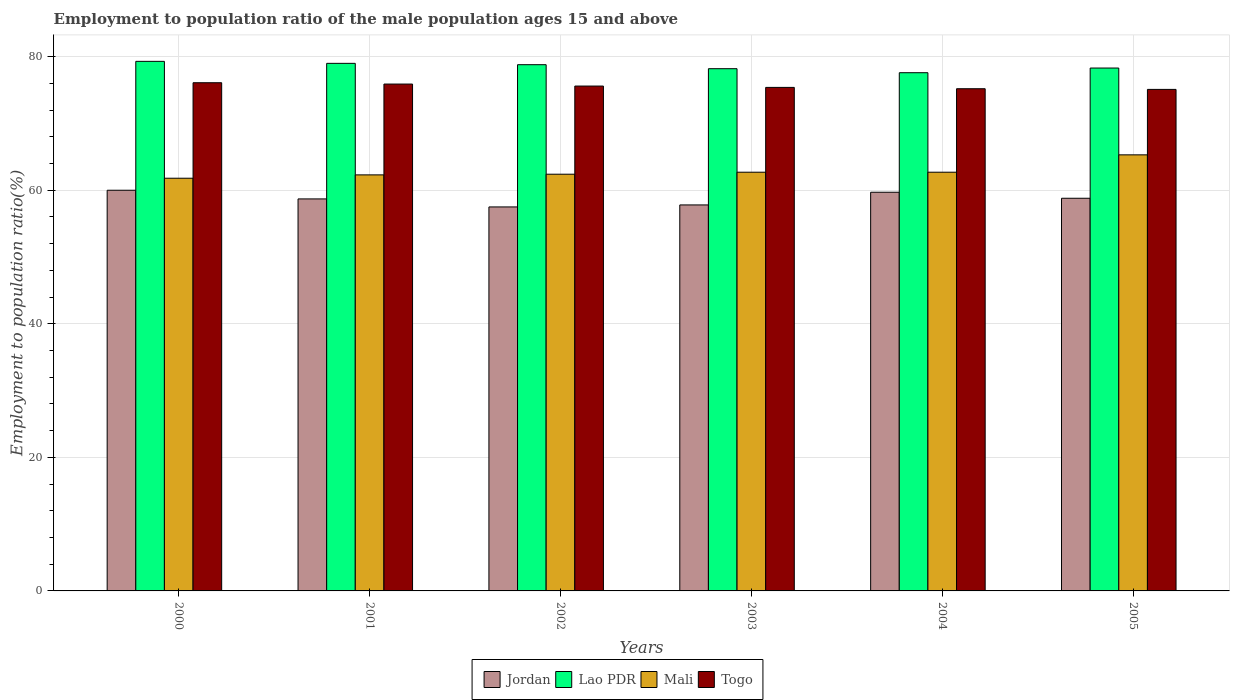Are the number of bars on each tick of the X-axis equal?
Provide a succinct answer. Yes. How many bars are there on the 1st tick from the right?
Make the answer very short. 4. What is the label of the 5th group of bars from the left?
Keep it short and to the point. 2004. In how many cases, is the number of bars for a given year not equal to the number of legend labels?
Provide a succinct answer. 0. What is the employment to population ratio in Jordan in 2001?
Keep it short and to the point. 58.7. Across all years, what is the maximum employment to population ratio in Lao PDR?
Offer a terse response. 79.3. Across all years, what is the minimum employment to population ratio in Togo?
Provide a short and direct response. 75.1. In which year was the employment to population ratio in Lao PDR maximum?
Make the answer very short. 2000. What is the total employment to population ratio in Mali in the graph?
Your answer should be very brief. 377.2. What is the difference between the employment to population ratio in Mali in 2000 and that in 2005?
Your answer should be compact. -3.5. What is the difference between the employment to population ratio in Jordan in 2003 and the employment to population ratio in Mali in 2004?
Provide a succinct answer. -4.9. What is the average employment to population ratio in Jordan per year?
Offer a terse response. 58.75. In the year 2004, what is the difference between the employment to population ratio in Lao PDR and employment to population ratio in Jordan?
Make the answer very short. 17.9. What is the ratio of the employment to population ratio in Mali in 2003 to that in 2004?
Offer a very short reply. 1. Is the difference between the employment to population ratio in Lao PDR in 2000 and 2002 greater than the difference between the employment to population ratio in Jordan in 2000 and 2002?
Ensure brevity in your answer.  No. What is the difference between the highest and the second highest employment to population ratio in Lao PDR?
Offer a terse response. 0.3. What is the difference between the highest and the lowest employment to population ratio in Lao PDR?
Provide a short and direct response. 1.7. Is it the case that in every year, the sum of the employment to population ratio in Togo and employment to population ratio in Mali is greater than the sum of employment to population ratio in Jordan and employment to population ratio in Lao PDR?
Provide a short and direct response. Yes. What does the 1st bar from the left in 2005 represents?
Your response must be concise. Jordan. What does the 3rd bar from the right in 2000 represents?
Offer a terse response. Lao PDR. How many bars are there?
Provide a short and direct response. 24. Are all the bars in the graph horizontal?
Your answer should be compact. No. Are the values on the major ticks of Y-axis written in scientific E-notation?
Your response must be concise. No. Does the graph contain any zero values?
Your answer should be very brief. No. Does the graph contain grids?
Make the answer very short. Yes. How many legend labels are there?
Keep it short and to the point. 4. What is the title of the graph?
Your answer should be very brief. Employment to population ratio of the male population ages 15 and above. What is the label or title of the X-axis?
Make the answer very short. Years. What is the Employment to population ratio(%) in Lao PDR in 2000?
Ensure brevity in your answer.  79.3. What is the Employment to population ratio(%) of Mali in 2000?
Provide a short and direct response. 61.8. What is the Employment to population ratio(%) in Togo in 2000?
Give a very brief answer. 76.1. What is the Employment to population ratio(%) in Jordan in 2001?
Your answer should be compact. 58.7. What is the Employment to population ratio(%) of Lao PDR in 2001?
Ensure brevity in your answer.  79. What is the Employment to population ratio(%) of Mali in 2001?
Offer a terse response. 62.3. What is the Employment to population ratio(%) in Togo in 2001?
Offer a terse response. 75.9. What is the Employment to population ratio(%) of Jordan in 2002?
Your response must be concise. 57.5. What is the Employment to population ratio(%) in Lao PDR in 2002?
Your answer should be compact. 78.8. What is the Employment to population ratio(%) in Mali in 2002?
Your answer should be compact. 62.4. What is the Employment to population ratio(%) of Togo in 2002?
Offer a very short reply. 75.6. What is the Employment to population ratio(%) of Jordan in 2003?
Your response must be concise. 57.8. What is the Employment to population ratio(%) in Lao PDR in 2003?
Ensure brevity in your answer.  78.2. What is the Employment to population ratio(%) of Mali in 2003?
Make the answer very short. 62.7. What is the Employment to population ratio(%) in Togo in 2003?
Offer a very short reply. 75.4. What is the Employment to population ratio(%) in Jordan in 2004?
Give a very brief answer. 59.7. What is the Employment to population ratio(%) in Lao PDR in 2004?
Make the answer very short. 77.6. What is the Employment to population ratio(%) in Mali in 2004?
Make the answer very short. 62.7. What is the Employment to population ratio(%) of Togo in 2004?
Make the answer very short. 75.2. What is the Employment to population ratio(%) in Jordan in 2005?
Provide a succinct answer. 58.8. What is the Employment to population ratio(%) in Lao PDR in 2005?
Ensure brevity in your answer.  78.3. What is the Employment to population ratio(%) of Mali in 2005?
Give a very brief answer. 65.3. What is the Employment to population ratio(%) in Togo in 2005?
Your answer should be very brief. 75.1. Across all years, what is the maximum Employment to population ratio(%) of Jordan?
Give a very brief answer. 60. Across all years, what is the maximum Employment to population ratio(%) of Lao PDR?
Make the answer very short. 79.3. Across all years, what is the maximum Employment to population ratio(%) of Mali?
Give a very brief answer. 65.3. Across all years, what is the maximum Employment to population ratio(%) of Togo?
Provide a succinct answer. 76.1. Across all years, what is the minimum Employment to population ratio(%) in Jordan?
Provide a short and direct response. 57.5. Across all years, what is the minimum Employment to population ratio(%) in Lao PDR?
Make the answer very short. 77.6. Across all years, what is the minimum Employment to population ratio(%) in Mali?
Provide a short and direct response. 61.8. Across all years, what is the minimum Employment to population ratio(%) in Togo?
Give a very brief answer. 75.1. What is the total Employment to population ratio(%) in Jordan in the graph?
Make the answer very short. 352.5. What is the total Employment to population ratio(%) in Lao PDR in the graph?
Your response must be concise. 471.2. What is the total Employment to population ratio(%) of Mali in the graph?
Offer a very short reply. 377.2. What is the total Employment to population ratio(%) of Togo in the graph?
Provide a short and direct response. 453.3. What is the difference between the Employment to population ratio(%) in Jordan in 2000 and that in 2001?
Offer a terse response. 1.3. What is the difference between the Employment to population ratio(%) in Togo in 2000 and that in 2001?
Your answer should be compact. 0.2. What is the difference between the Employment to population ratio(%) of Togo in 2000 and that in 2002?
Keep it short and to the point. 0.5. What is the difference between the Employment to population ratio(%) in Jordan in 2000 and that in 2003?
Provide a short and direct response. 2.2. What is the difference between the Employment to population ratio(%) of Mali in 2000 and that in 2003?
Your response must be concise. -0.9. What is the difference between the Employment to population ratio(%) of Jordan in 2000 and that in 2004?
Offer a very short reply. 0.3. What is the difference between the Employment to population ratio(%) of Mali in 2000 and that in 2004?
Offer a terse response. -0.9. What is the difference between the Employment to population ratio(%) of Togo in 2000 and that in 2004?
Your answer should be very brief. 0.9. What is the difference between the Employment to population ratio(%) in Jordan in 2000 and that in 2005?
Your answer should be compact. 1.2. What is the difference between the Employment to population ratio(%) in Mali in 2000 and that in 2005?
Keep it short and to the point. -3.5. What is the difference between the Employment to population ratio(%) in Togo in 2000 and that in 2005?
Your answer should be compact. 1. What is the difference between the Employment to population ratio(%) in Lao PDR in 2001 and that in 2002?
Your answer should be compact. 0.2. What is the difference between the Employment to population ratio(%) of Mali in 2001 and that in 2002?
Ensure brevity in your answer.  -0.1. What is the difference between the Employment to population ratio(%) in Togo in 2001 and that in 2002?
Offer a terse response. 0.3. What is the difference between the Employment to population ratio(%) of Jordan in 2001 and that in 2003?
Offer a very short reply. 0.9. What is the difference between the Employment to population ratio(%) in Lao PDR in 2001 and that in 2003?
Your answer should be very brief. 0.8. What is the difference between the Employment to population ratio(%) in Mali in 2001 and that in 2003?
Provide a short and direct response. -0.4. What is the difference between the Employment to population ratio(%) in Mali in 2001 and that in 2004?
Provide a short and direct response. -0.4. What is the difference between the Employment to population ratio(%) in Jordan in 2001 and that in 2005?
Offer a terse response. -0.1. What is the difference between the Employment to population ratio(%) of Lao PDR in 2001 and that in 2005?
Provide a succinct answer. 0.7. What is the difference between the Employment to population ratio(%) in Togo in 2001 and that in 2005?
Offer a very short reply. 0.8. What is the difference between the Employment to population ratio(%) in Jordan in 2002 and that in 2003?
Offer a very short reply. -0.3. What is the difference between the Employment to population ratio(%) of Mali in 2003 and that in 2004?
Ensure brevity in your answer.  0. What is the difference between the Employment to population ratio(%) in Togo in 2003 and that in 2004?
Offer a very short reply. 0.2. What is the difference between the Employment to population ratio(%) of Mali in 2003 and that in 2005?
Offer a terse response. -2.6. What is the difference between the Employment to population ratio(%) in Lao PDR in 2004 and that in 2005?
Your answer should be very brief. -0.7. What is the difference between the Employment to population ratio(%) of Togo in 2004 and that in 2005?
Give a very brief answer. 0.1. What is the difference between the Employment to population ratio(%) in Jordan in 2000 and the Employment to population ratio(%) in Lao PDR in 2001?
Provide a short and direct response. -19. What is the difference between the Employment to population ratio(%) in Jordan in 2000 and the Employment to population ratio(%) in Togo in 2001?
Provide a short and direct response. -15.9. What is the difference between the Employment to population ratio(%) in Lao PDR in 2000 and the Employment to population ratio(%) in Mali in 2001?
Give a very brief answer. 17. What is the difference between the Employment to population ratio(%) of Mali in 2000 and the Employment to population ratio(%) of Togo in 2001?
Your answer should be very brief. -14.1. What is the difference between the Employment to population ratio(%) in Jordan in 2000 and the Employment to population ratio(%) in Lao PDR in 2002?
Offer a very short reply. -18.8. What is the difference between the Employment to population ratio(%) of Jordan in 2000 and the Employment to population ratio(%) of Mali in 2002?
Your response must be concise. -2.4. What is the difference between the Employment to population ratio(%) in Jordan in 2000 and the Employment to population ratio(%) in Togo in 2002?
Provide a succinct answer. -15.6. What is the difference between the Employment to population ratio(%) in Lao PDR in 2000 and the Employment to population ratio(%) in Mali in 2002?
Your answer should be compact. 16.9. What is the difference between the Employment to population ratio(%) of Lao PDR in 2000 and the Employment to population ratio(%) of Togo in 2002?
Your answer should be compact. 3.7. What is the difference between the Employment to population ratio(%) of Jordan in 2000 and the Employment to population ratio(%) of Lao PDR in 2003?
Provide a short and direct response. -18.2. What is the difference between the Employment to population ratio(%) of Jordan in 2000 and the Employment to population ratio(%) of Togo in 2003?
Offer a very short reply. -15.4. What is the difference between the Employment to population ratio(%) in Lao PDR in 2000 and the Employment to population ratio(%) in Mali in 2003?
Ensure brevity in your answer.  16.6. What is the difference between the Employment to population ratio(%) in Mali in 2000 and the Employment to population ratio(%) in Togo in 2003?
Provide a succinct answer. -13.6. What is the difference between the Employment to population ratio(%) of Jordan in 2000 and the Employment to population ratio(%) of Lao PDR in 2004?
Provide a short and direct response. -17.6. What is the difference between the Employment to population ratio(%) of Jordan in 2000 and the Employment to population ratio(%) of Togo in 2004?
Make the answer very short. -15.2. What is the difference between the Employment to population ratio(%) of Lao PDR in 2000 and the Employment to population ratio(%) of Mali in 2004?
Your response must be concise. 16.6. What is the difference between the Employment to population ratio(%) of Mali in 2000 and the Employment to population ratio(%) of Togo in 2004?
Make the answer very short. -13.4. What is the difference between the Employment to population ratio(%) of Jordan in 2000 and the Employment to population ratio(%) of Lao PDR in 2005?
Ensure brevity in your answer.  -18.3. What is the difference between the Employment to population ratio(%) in Jordan in 2000 and the Employment to population ratio(%) in Togo in 2005?
Your answer should be compact. -15.1. What is the difference between the Employment to population ratio(%) in Jordan in 2001 and the Employment to population ratio(%) in Lao PDR in 2002?
Your answer should be compact. -20.1. What is the difference between the Employment to population ratio(%) of Jordan in 2001 and the Employment to population ratio(%) of Mali in 2002?
Give a very brief answer. -3.7. What is the difference between the Employment to population ratio(%) in Jordan in 2001 and the Employment to population ratio(%) in Togo in 2002?
Ensure brevity in your answer.  -16.9. What is the difference between the Employment to population ratio(%) of Lao PDR in 2001 and the Employment to population ratio(%) of Togo in 2002?
Your answer should be very brief. 3.4. What is the difference between the Employment to population ratio(%) in Jordan in 2001 and the Employment to population ratio(%) in Lao PDR in 2003?
Provide a short and direct response. -19.5. What is the difference between the Employment to population ratio(%) in Jordan in 2001 and the Employment to population ratio(%) in Togo in 2003?
Give a very brief answer. -16.7. What is the difference between the Employment to population ratio(%) in Lao PDR in 2001 and the Employment to population ratio(%) in Mali in 2003?
Provide a short and direct response. 16.3. What is the difference between the Employment to population ratio(%) of Jordan in 2001 and the Employment to population ratio(%) of Lao PDR in 2004?
Provide a succinct answer. -18.9. What is the difference between the Employment to population ratio(%) of Jordan in 2001 and the Employment to population ratio(%) of Togo in 2004?
Your response must be concise. -16.5. What is the difference between the Employment to population ratio(%) of Lao PDR in 2001 and the Employment to population ratio(%) of Togo in 2004?
Make the answer very short. 3.8. What is the difference between the Employment to population ratio(%) of Jordan in 2001 and the Employment to population ratio(%) of Lao PDR in 2005?
Make the answer very short. -19.6. What is the difference between the Employment to population ratio(%) in Jordan in 2001 and the Employment to population ratio(%) in Mali in 2005?
Ensure brevity in your answer.  -6.6. What is the difference between the Employment to population ratio(%) of Jordan in 2001 and the Employment to population ratio(%) of Togo in 2005?
Offer a very short reply. -16.4. What is the difference between the Employment to population ratio(%) in Lao PDR in 2001 and the Employment to population ratio(%) in Togo in 2005?
Provide a succinct answer. 3.9. What is the difference between the Employment to population ratio(%) in Jordan in 2002 and the Employment to population ratio(%) in Lao PDR in 2003?
Your answer should be very brief. -20.7. What is the difference between the Employment to population ratio(%) in Jordan in 2002 and the Employment to population ratio(%) in Togo in 2003?
Provide a succinct answer. -17.9. What is the difference between the Employment to population ratio(%) in Lao PDR in 2002 and the Employment to population ratio(%) in Mali in 2003?
Make the answer very short. 16.1. What is the difference between the Employment to population ratio(%) in Mali in 2002 and the Employment to population ratio(%) in Togo in 2003?
Make the answer very short. -13. What is the difference between the Employment to population ratio(%) of Jordan in 2002 and the Employment to population ratio(%) of Lao PDR in 2004?
Your answer should be very brief. -20.1. What is the difference between the Employment to population ratio(%) in Jordan in 2002 and the Employment to population ratio(%) in Togo in 2004?
Make the answer very short. -17.7. What is the difference between the Employment to population ratio(%) in Lao PDR in 2002 and the Employment to population ratio(%) in Mali in 2004?
Give a very brief answer. 16.1. What is the difference between the Employment to population ratio(%) of Lao PDR in 2002 and the Employment to population ratio(%) of Togo in 2004?
Your answer should be compact. 3.6. What is the difference between the Employment to population ratio(%) of Mali in 2002 and the Employment to population ratio(%) of Togo in 2004?
Make the answer very short. -12.8. What is the difference between the Employment to population ratio(%) of Jordan in 2002 and the Employment to population ratio(%) of Lao PDR in 2005?
Offer a terse response. -20.8. What is the difference between the Employment to population ratio(%) in Jordan in 2002 and the Employment to population ratio(%) in Mali in 2005?
Offer a very short reply. -7.8. What is the difference between the Employment to population ratio(%) in Jordan in 2002 and the Employment to population ratio(%) in Togo in 2005?
Your answer should be compact. -17.6. What is the difference between the Employment to population ratio(%) in Lao PDR in 2002 and the Employment to population ratio(%) in Togo in 2005?
Ensure brevity in your answer.  3.7. What is the difference between the Employment to population ratio(%) of Mali in 2002 and the Employment to population ratio(%) of Togo in 2005?
Keep it short and to the point. -12.7. What is the difference between the Employment to population ratio(%) in Jordan in 2003 and the Employment to population ratio(%) in Lao PDR in 2004?
Give a very brief answer. -19.8. What is the difference between the Employment to population ratio(%) of Jordan in 2003 and the Employment to population ratio(%) of Togo in 2004?
Your answer should be very brief. -17.4. What is the difference between the Employment to population ratio(%) in Lao PDR in 2003 and the Employment to population ratio(%) in Mali in 2004?
Your answer should be compact. 15.5. What is the difference between the Employment to population ratio(%) in Lao PDR in 2003 and the Employment to population ratio(%) in Togo in 2004?
Offer a terse response. 3. What is the difference between the Employment to population ratio(%) of Mali in 2003 and the Employment to population ratio(%) of Togo in 2004?
Provide a short and direct response. -12.5. What is the difference between the Employment to population ratio(%) in Jordan in 2003 and the Employment to population ratio(%) in Lao PDR in 2005?
Your answer should be compact. -20.5. What is the difference between the Employment to population ratio(%) of Jordan in 2003 and the Employment to population ratio(%) of Togo in 2005?
Your answer should be very brief. -17.3. What is the difference between the Employment to population ratio(%) of Lao PDR in 2003 and the Employment to population ratio(%) of Mali in 2005?
Your response must be concise. 12.9. What is the difference between the Employment to population ratio(%) of Mali in 2003 and the Employment to population ratio(%) of Togo in 2005?
Your response must be concise. -12.4. What is the difference between the Employment to population ratio(%) of Jordan in 2004 and the Employment to population ratio(%) of Lao PDR in 2005?
Your answer should be compact. -18.6. What is the difference between the Employment to population ratio(%) of Jordan in 2004 and the Employment to population ratio(%) of Mali in 2005?
Give a very brief answer. -5.6. What is the difference between the Employment to population ratio(%) of Jordan in 2004 and the Employment to population ratio(%) of Togo in 2005?
Ensure brevity in your answer.  -15.4. What is the difference between the Employment to population ratio(%) in Lao PDR in 2004 and the Employment to population ratio(%) in Mali in 2005?
Ensure brevity in your answer.  12.3. What is the difference between the Employment to population ratio(%) in Lao PDR in 2004 and the Employment to population ratio(%) in Togo in 2005?
Keep it short and to the point. 2.5. What is the difference between the Employment to population ratio(%) of Mali in 2004 and the Employment to population ratio(%) of Togo in 2005?
Keep it short and to the point. -12.4. What is the average Employment to population ratio(%) in Jordan per year?
Ensure brevity in your answer.  58.75. What is the average Employment to population ratio(%) of Lao PDR per year?
Your response must be concise. 78.53. What is the average Employment to population ratio(%) of Mali per year?
Ensure brevity in your answer.  62.87. What is the average Employment to population ratio(%) in Togo per year?
Ensure brevity in your answer.  75.55. In the year 2000, what is the difference between the Employment to population ratio(%) in Jordan and Employment to population ratio(%) in Lao PDR?
Your answer should be very brief. -19.3. In the year 2000, what is the difference between the Employment to population ratio(%) of Jordan and Employment to population ratio(%) of Togo?
Your answer should be compact. -16.1. In the year 2000, what is the difference between the Employment to population ratio(%) in Lao PDR and Employment to population ratio(%) in Mali?
Ensure brevity in your answer.  17.5. In the year 2000, what is the difference between the Employment to population ratio(%) in Lao PDR and Employment to population ratio(%) in Togo?
Give a very brief answer. 3.2. In the year 2000, what is the difference between the Employment to population ratio(%) in Mali and Employment to population ratio(%) in Togo?
Give a very brief answer. -14.3. In the year 2001, what is the difference between the Employment to population ratio(%) of Jordan and Employment to population ratio(%) of Lao PDR?
Provide a short and direct response. -20.3. In the year 2001, what is the difference between the Employment to population ratio(%) in Jordan and Employment to population ratio(%) in Mali?
Your answer should be compact. -3.6. In the year 2001, what is the difference between the Employment to population ratio(%) of Jordan and Employment to population ratio(%) of Togo?
Provide a succinct answer. -17.2. In the year 2001, what is the difference between the Employment to population ratio(%) of Lao PDR and Employment to population ratio(%) of Mali?
Provide a succinct answer. 16.7. In the year 2001, what is the difference between the Employment to population ratio(%) of Mali and Employment to population ratio(%) of Togo?
Your answer should be very brief. -13.6. In the year 2002, what is the difference between the Employment to population ratio(%) in Jordan and Employment to population ratio(%) in Lao PDR?
Offer a very short reply. -21.3. In the year 2002, what is the difference between the Employment to population ratio(%) of Jordan and Employment to population ratio(%) of Mali?
Your answer should be compact. -4.9. In the year 2002, what is the difference between the Employment to population ratio(%) of Jordan and Employment to population ratio(%) of Togo?
Your answer should be very brief. -18.1. In the year 2002, what is the difference between the Employment to population ratio(%) in Mali and Employment to population ratio(%) in Togo?
Your answer should be compact. -13.2. In the year 2003, what is the difference between the Employment to population ratio(%) in Jordan and Employment to population ratio(%) in Lao PDR?
Keep it short and to the point. -20.4. In the year 2003, what is the difference between the Employment to population ratio(%) of Jordan and Employment to population ratio(%) of Togo?
Provide a succinct answer. -17.6. In the year 2003, what is the difference between the Employment to population ratio(%) in Lao PDR and Employment to population ratio(%) in Togo?
Give a very brief answer. 2.8. In the year 2004, what is the difference between the Employment to population ratio(%) of Jordan and Employment to population ratio(%) of Lao PDR?
Your response must be concise. -17.9. In the year 2004, what is the difference between the Employment to population ratio(%) in Jordan and Employment to population ratio(%) in Mali?
Provide a succinct answer. -3. In the year 2004, what is the difference between the Employment to population ratio(%) of Jordan and Employment to population ratio(%) of Togo?
Offer a terse response. -15.5. In the year 2004, what is the difference between the Employment to population ratio(%) of Lao PDR and Employment to population ratio(%) of Mali?
Your answer should be compact. 14.9. In the year 2004, what is the difference between the Employment to population ratio(%) in Mali and Employment to population ratio(%) in Togo?
Provide a succinct answer. -12.5. In the year 2005, what is the difference between the Employment to population ratio(%) of Jordan and Employment to population ratio(%) of Lao PDR?
Make the answer very short. -19.5. In the year 2005, what is the difference between the Employment to population ratio(%) in Jordan and Employment to population ratio(%) in Mali?
Your answer should be compact. -6.5. In the year 2005, what is the difference between the Employment to population ratio(%) of Jordan and Employment to population ratio(%) of Togo?
Keep it short and to the point. -16.3. In the year 2005, what is the difference between the Employment to population ratio(%) in Lao PDR and Employment to population ratio(%) in Mali?
Provide a short and direct response. 13. In the year 2005, what is the difference between the Employment to population ratio(%) of Mali and Employment to population ratio(%) of Togo?
Your answer should be compact. -9.8. What is the ratio of the Employment to population ratio(%) of Jordan in 2000 to that in 2001?
Your response must be concise. 1.02. What is the ratio of the Employment to population ratio(%) of Lao PDR in 2000 to that in 2001?
Provide a succinct answer. 1. What is the ratio of the Employment to population ratio(%) in Jordan in 2000 to that in 2002?
Ensure brevity in your answer.  1.04. What is the ratio of the Employment to population ratio(%) in Lao PDR in 2000 to that in 2002?
Provide a succinct answer. 1.01. What is the ratio of the Employment to population ratio(%) in Mali in 2000 to that in 2002?
Ensure brevity in your answer.  0.99. What is the ratio of the Employment to population ratio(%) of Togo in 2000 to that in 2002?
Provide a short and direct response. 1.01. What is the ratio of the Employment to population ratio(%) in Jordan in 2000 to that in 2003?
Offer a very short reply. 1.04. What is the ratio of the Employment to population ratio(%) of Lao PDR in 2000 to that in 2003?
Your answer should be compact. 1.01. What is the ratio of the Employment to population ratio(%) in Mali in 2000 to that in 2003?
Provide a short and direct response. 0.99. What is the ratio of the Employment to population ratio(%) of Togo in 2000 to that in 2003?
Offer a very short reply. 1.01. What is the ratio of the Employment to population ratio(%) in Lao PDR in 2000 to that in 2004?
Make the answer very short. 1.02. What is the ratio of the Employment to population ratio(%) of Mali in 2000 to that in 2004?
Give a very brief answer. 0.99. What is the ratio of the Employment to population ratio(%) in Togo in 2000 to that in 2004?
Your response must be concise. 1.01. What is the ratio of the Employment to population ratio(%) of Jordan in 2000 to that in 2005?
Keep it short and to the point. 1.02. What is the ratio of the Employment to population ratio(%) in Lao PDR in 2000 to that in 2005?
Your response must be concise. 1.01. What is the ratio of the Employment to population ratio(%) of Mali in 2000 to that in 2005?
Your answer should be compact. 0.95. What is the ratio of the Employment to population ratio(%) in Togo in 2000 to that in 2005?
Provide a short and direct response. 1.01. What is the ratio of the Employment to population ratio(%) in Jordan in 2001 to that in 2002?
Provide a short and direct response. 1.02. What is the ratio of the Employment to population ratio(%) of Lao PDR in 2001 to that in 2002?
Offer a terse response. 1. What is the ratio of the Employment to population ratio(%) of Mali in 2001 to that in 2002?
Your response must be concise. 1. What is the ratio of the Employment to population ratio(%) in Jordan in 2001 to that in 2003?
Give a very brief answer. 1.02. What is the ratio of the Employment to population ratio(%) in Lao PDR in 2001 to that in 2003?
Offer a very short reply. 1.01. What is the ratio of the Employment to population ratio(%) in Mali in 2001 to that in 2003?
Your answer should be very brief. 0.99. What is the ratio of the Employment to population ratio(%) in Togo in 2001 to that in 2003?
Provide a short and direct response. 1.01. What is the ratio of the Employment to population ratio(%) of Jordan in 2001 to that in 2004?
Make the answer very short. 0.98. What is the ratio of the Employment to population ratio(%) in Lao PDR in 2001 to that in 2004?
Offer a terse response. 1.02. What is the ratio of the Employment to population ratio(%) of Togo in 2001 to that in 2004?
Provide a short and direct response. 1.01. What is the ratio of the Employment to population ratio(%) in Lao PDR in 2001 to that in 2005?
Provide a succinct answer. 1.01. What is the ratio of the Employment to population ratio(%) in Mali in 2001 to that in 2005?
Your response must be concise. 0.95. What is the ratio of the Employment to population ratio(%) of Togo in 2001 to that in 2005?
Give a very brief answer. 1.01. What is the ratio of the Employment to population ratio(%) in Jordan in 2002 to that in 2003?
Your answer should be very brief. 0.99. What is the ratio of the Employment to population ratio(%) in Lao PDR in 2002 to that in 2003?
Your answer should be very brief. 1.01. What is the ratio of the Employment to population ratio(%) in Jordan in 2002 to that in 2004?
Offer a very short reply. 0.96. What is the ratio of the Employment to population ratio(%) of Lao PDR in 2002 to that in 2004?
Provide a short and direct response. 1.02. What is the ratio of the Employment to population ratio(%) in Mali in 2002 to that in 2004?
Make the answer very short. 1. What is the ratio of the Employment to population ratio(%) in Jordan in 2002 to that in 2005?
Give a very brief answer. 0.98. What is the ratio of the Employment to population ratio(%) in Lao PDR in 2002 to that in 2005?
Your answer should be compact. 1.01. What is the ratio of the Employment to population ratio(%) in Mali in 2002 to that in 2005?
Your answer should be compact. 0.96. What is the ratio of the Employment to population ratio(%) of Jordan in 2003 to that in 2004?
Make the answer very short. 0.97. What is the ratio of the Employment to population ratio(%) in Lao PDR in 2003 to that in 2004?
Make the answer very short. 1.01. What is the ratio of the Employment to population ratio(%) in Mali in 2003 to that in 2004?
Offer a terse response. 1. What is the ratio of the Employment to population ratio(%) of Mali in 2003 to that in 2005?
Give a very brief answer. 0.96. What is the ratio of the Employment to population ratio(%) in Togo in 2003 to that in 2005?
Keep it short and to the point. 1. What is the ratio of the Employment to population ratio(%) in Jordan in 2004 to that in 2005?
Your answer should be very brief. 1.02. What is the ratio of the Employment to population ratio(%) in Lao PDR in 2004 to that in 2005?
Your answer should be compact. 0.99. What is the ratio of the Employment to population ratio(%) of Mali in 2004 to that in 2005?
Ensure brevity in your answer.  0.96. What is the ratio of the Employment to population ratio(%) of Togo in 2004 to that in 2005?
Your response must be concise. 1. What is the difference between the highest and the second highest Employment to population ratio(%) in Jordan?
Your answer should be very brief. 0.3. 